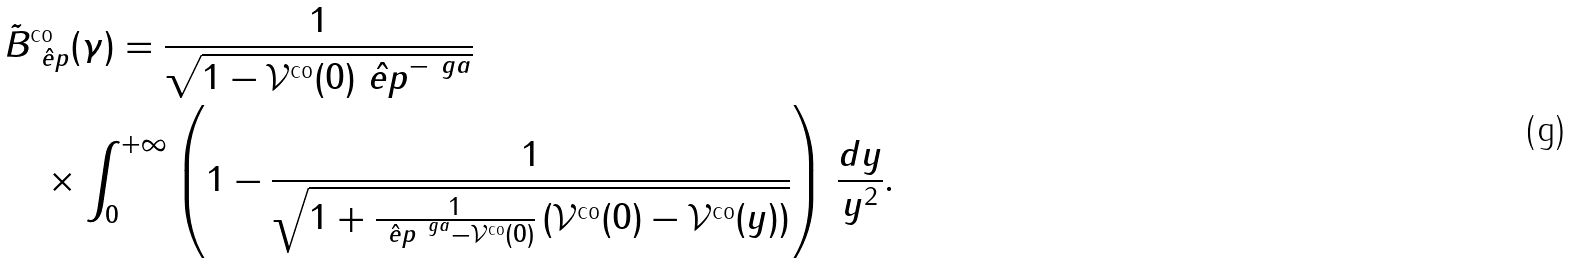<formula> <loc_0><loc_0><loc_500><loc_500>& \tilde { B } _ { \hat { \ e p } } ^ { \text {co} } ( \gamma ) = \frac { 1 } { \sqrt { 1 - \mathcal { V } ^ { \text {co} } ( 0 ) \hat { \ e p } ^ { - \ g a } } } \\ & \quad \times \int _ { 0 } ^ { + \infty } \left ( 1 - \frac { 1 } { \sqrt { 1 + \frac { 1 } { \hat { \ e p } ^ { \ g a } - \mathcal { V } ^ { \text {co} } ( 0 ) } \left ( \mathcal { V } ^ { \text {co} } ( 0 ) - \mathcal { V } ^ { \text {co} } ( y ) \right ) } } \right ) \, \frac { d y } { y ^ { 2 } } .</formula> 